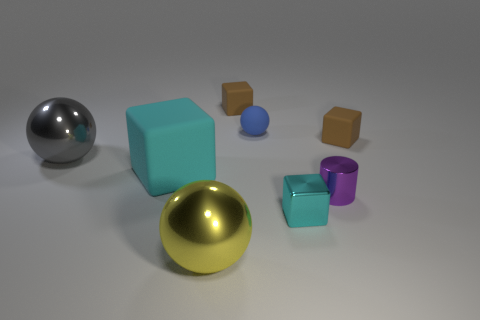Subtract all big shiny spheres. How many spheres are left? 1 Subtract all cyan cubes. How many cubes are left? 2 Subtract all balls. How many objects are left? 5 Add 1 large metal objects. How many objects exist? 9 Subtract 2 blocks. How many blocks are left? 2 Add 2 small green rubber spheres. How many small green rubber spheres exist? 2 Subtract 0 cyan cylinders. How many objects are left? 8 Subtract all gray blocks. Subtract all red cylinders. How many blocks are left? 4 Subtract all gray spheres. How many brown cubes are left? 2 Subtract all small cyan metal blocks. Subtract all yellow metal things. How many objects are left? 6 